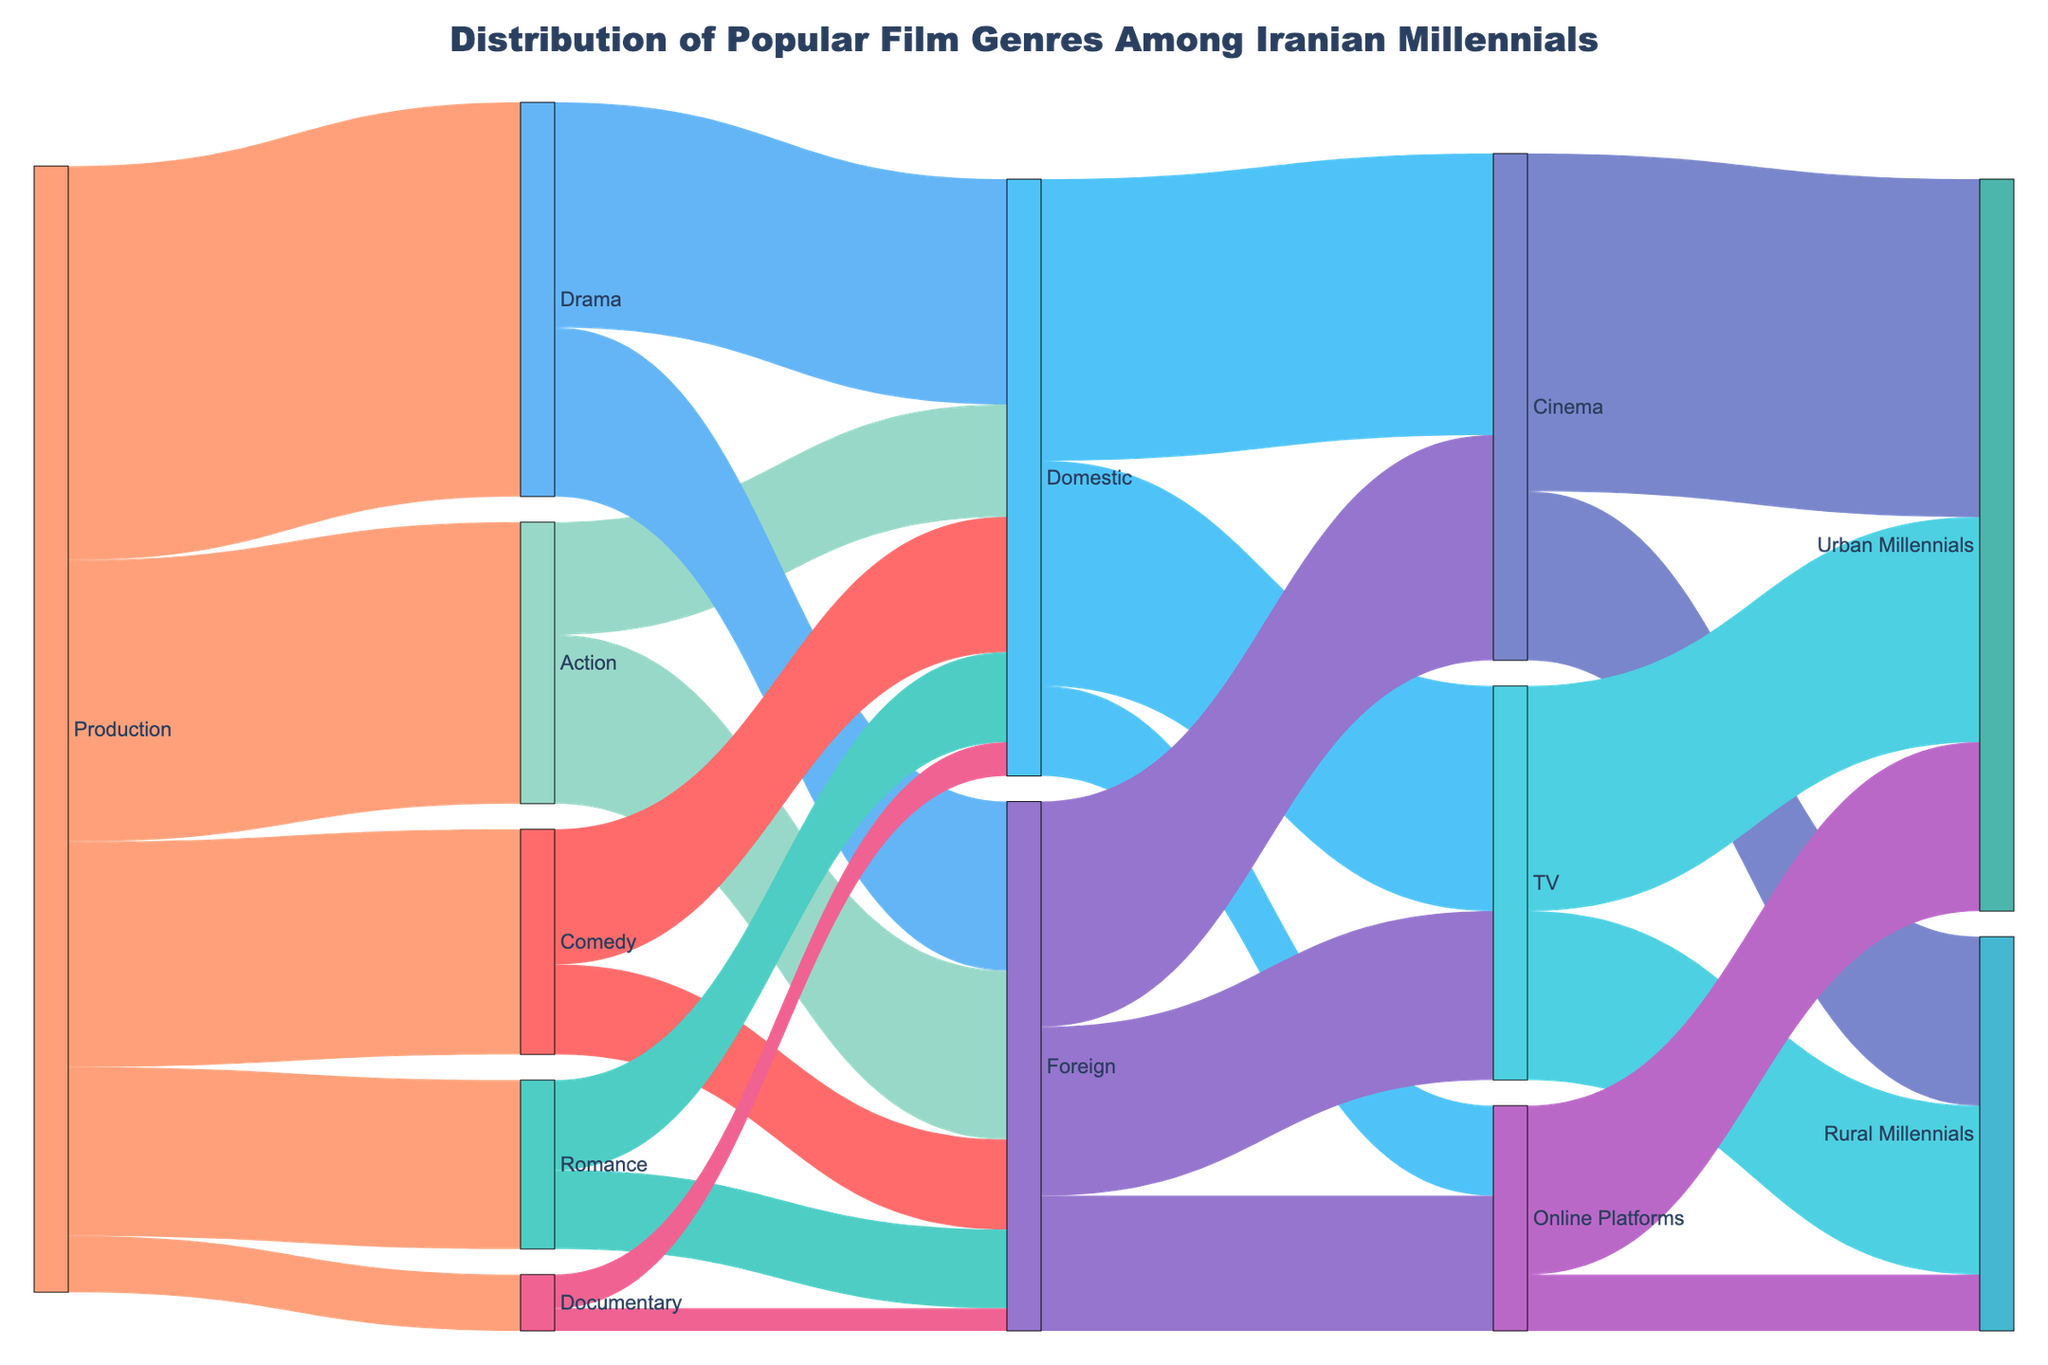What is the title of the diagram? The title is usually found at the top of the diagram. In this case, it reads "Distribution of Popular Film Genres Among Iranian Millennials".
Answer: Distribution of Popular Film Genres Among Iranian Millennials Which film genre has the highest production value? By looking at the thickness of the lines (which indicates the value) emanating from "Production" to each genre, the "Drama" genre has the thickest line. According to the data, Drama has a value of 35.
Answer: Drama How many domestic Action films were produced? The line from "Action" to "Domestic" represents the number of domestic Action films. According to the data, this value is 10.
Answer: 10 What is the total number of Urban Millennials watching films via TV? Add the number of Domestic and Foreign TV viewerships for Urban Millennials: Domestic (20) + Foreign (15). Therefore, the total is 20 + 15 = 35.
Answer: 35 Compare the number of films watched on Online Platforms by Urban and Rural Millennials. Who watches more, and by how much? Urban Millennials watch 15 films on Online Platforms; Rural Millennials watch 5. To find the difference, subtract the rural amount from the urban amount: 15 - 5 = 10. So, Urban Millennials watch 10 more films.
Answer: Urban Millennials by 10 How many more Drama films are watched domestically compared to foreign? According to the data, 20 domestic Drama films are watched compared to 15 foreign Drama films. The difference is 20 - 15 = 5.
Answer: 5 What is the combined total value of Romance films, both domestic and foreign? Add the value of domestic Romance films (8) and foreign Romance films (7): 8 + 7 = 15.
Answer: 15 Which viewing platform has the highest consumption by Urban Millennials? To compare the platforms, look at the values for Urban Millennials: Cinema (30), TV (20), and Online Platforms (15). The highest value is for Cinema, which is 30.
Answer: Cinema Which genre has the least number of Domestic films produced? According to the data, the Documentary genre has the least number of domestic films, with a value of 3.
Answer: Documentary Compare the production values of Comedy and Romance genres. Which one has a higher value and by how much? Comedy has a production value of 20, and Romance has a production value of 15. So, Comedy has a higher value by 20 - 15 = 5.
Answer: Comedy by 5 